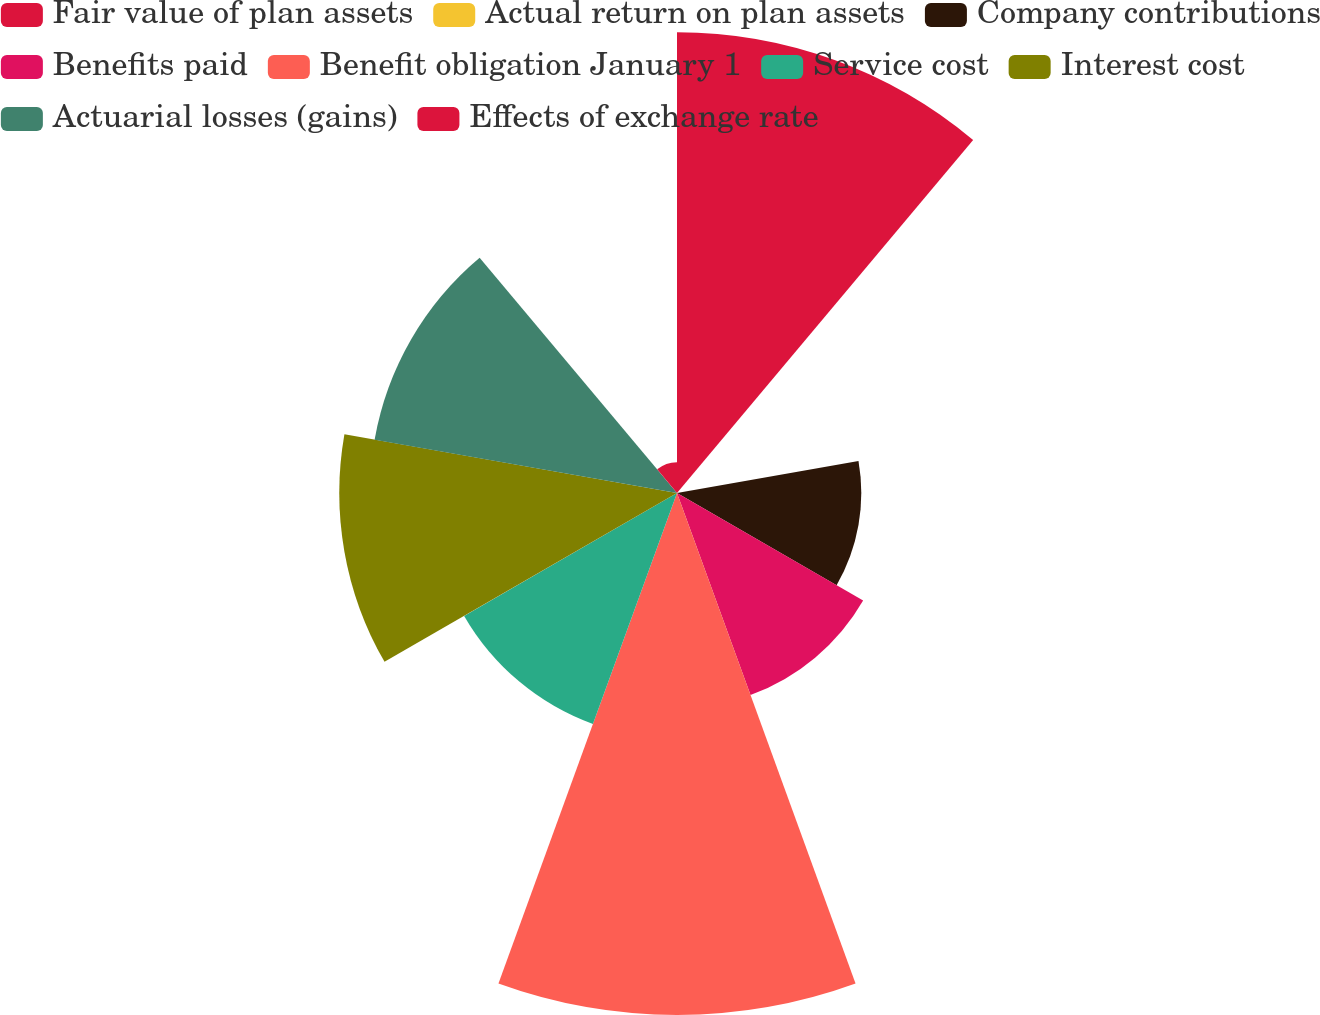Convert chart to OTSL. <chart><loc_0><loc_0><loc_500><loc_500><pie_chart><fcel>Fair value of plan assets<fcel>Actual return on plan assets<fcel>Company contributions<fcel>Benefits paid<fcel>Benefit obligation January 1<fcel>Service cost<fcel>Interest cost<fcel>Actuarial losses (gains)<fcel>Effects of exchange rate<nl><fcel>20.0%<fcel>0.01%<fcel>8.0%<fcel>9.33%<fcel>22.66%<fcel>10.67%<fcel>14.66%<fcel>13.33%<fcel>1.34%<nl></chart> 